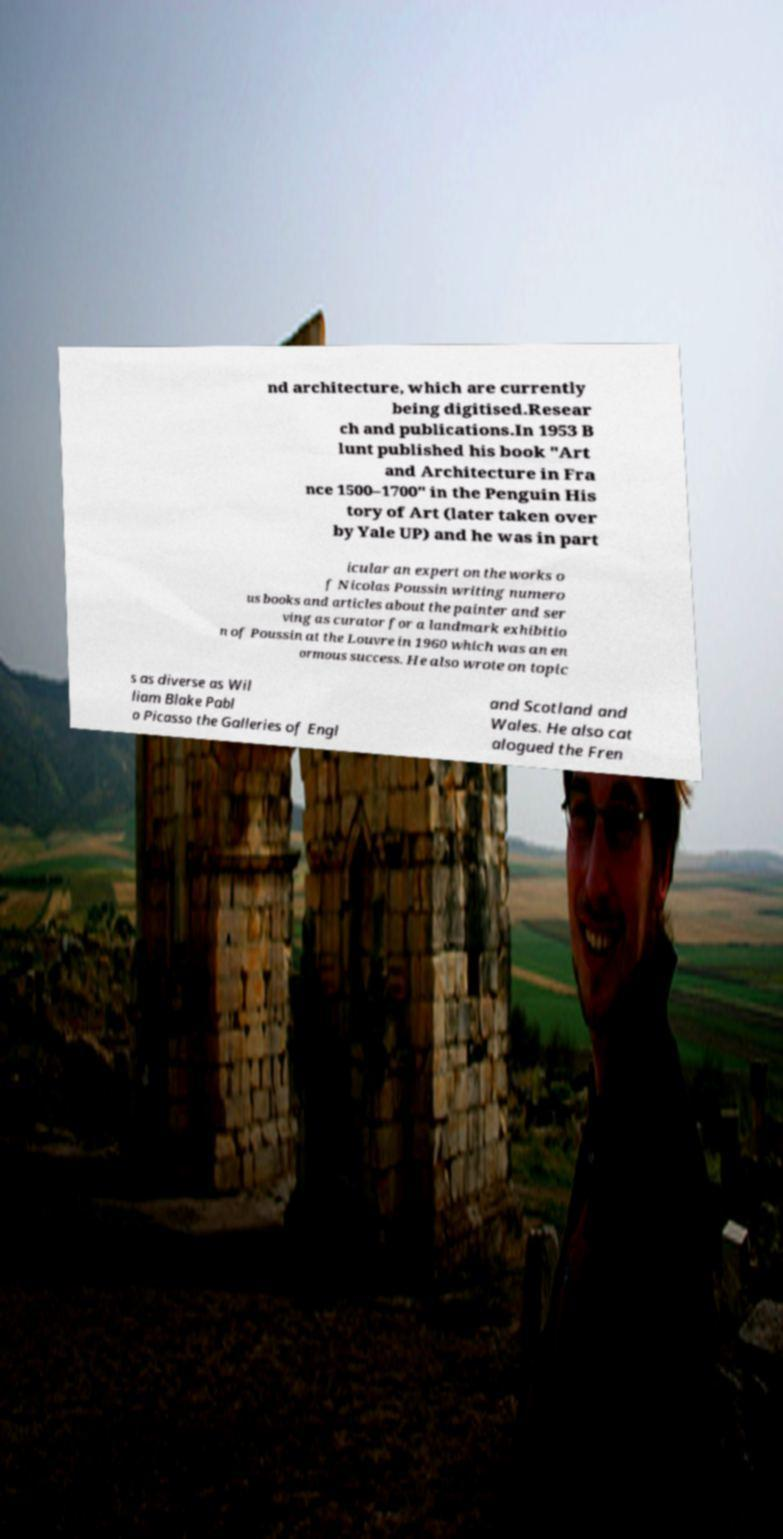Could you extract and type out the text from this image? nd architecture, which are currently being digitised.Resear ch and publications.In 1953 B lunt published his book "Art and Architecture in Fra nce 1500–1700" in the Penguin His tory of Art (later taken over by Yale UP) and he was in part icular an expert on the works o f Nicolas Poussin writing numero us books and articles about the painter and ser ving as curator for a landmark exhibitio n of Poussin at the Louvre in 1960 which was an en ormous success. He also wrote on topic s as diverse as Wil liam Blake Pabl o Picasso the Galleries of Engl and Scotland and Wales. He also cat alogued the Fren 